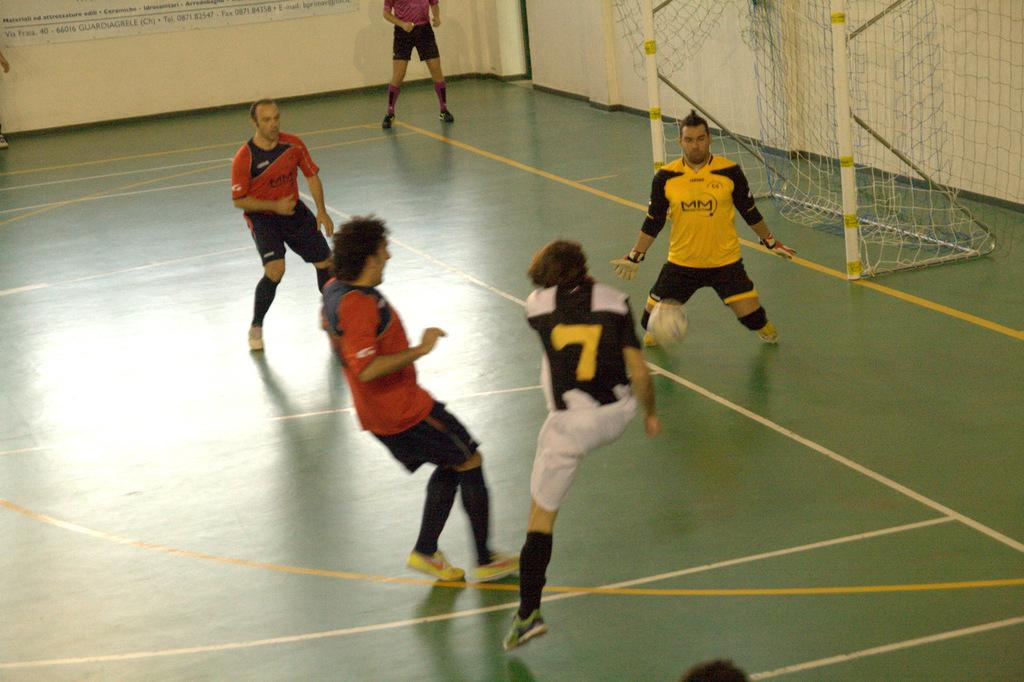What type of sports facility is shown in the image? There is a handball court in the image. What activity is taking place on the court? Players are playing a game on the court. What is the main feature of the court that is used to score points? There is a goal post in the image. What year was the handball court built, and who designed it? The provided facts do not include information about the year the handball court was built or the designer, so we cannot answer this question. 